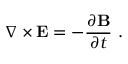<formula> <loc_0><loc_0><loc_500><loc_500>\nabla \times E = - { \frac { \partial B } { \partial t } } \ .</formula> 